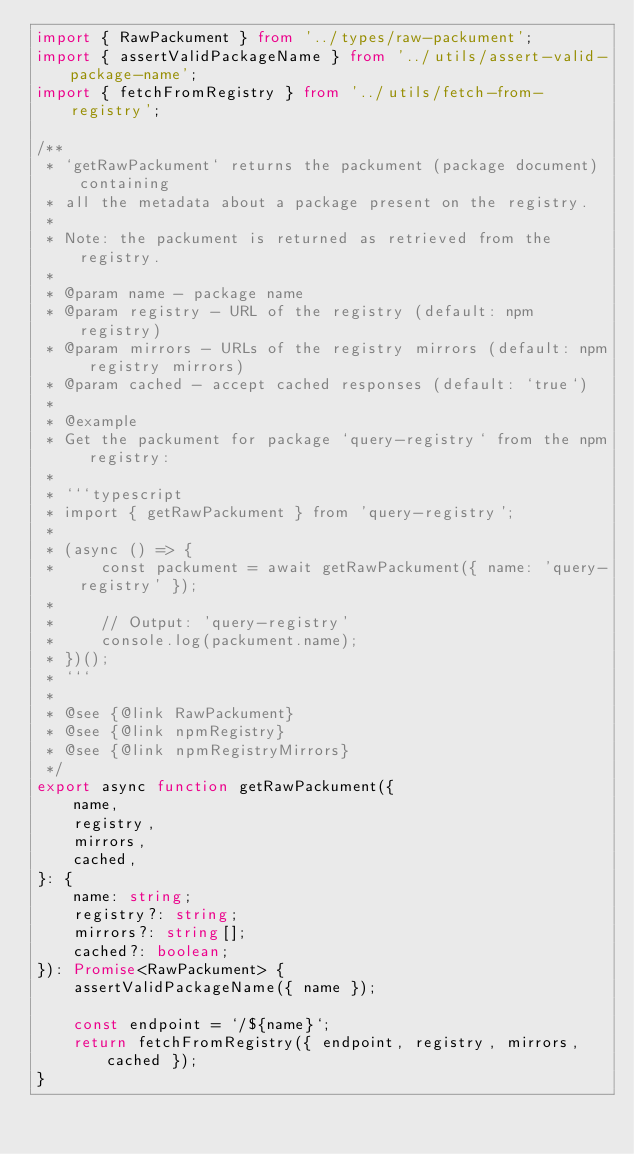Convert code to text. <code><loc_0><loc_0><loc_500><loc_500><_TypeScript_>import { RawPackument } from '../types/raw-packument';
import { assertValidPackageName } from '../utils/assert-valid-package-name';
import { fetchFromRegistry } from '../utils/fetch-from-registry';

/**
 * `getRawPackument` returns the packument (package document) containing
 * all the metadata about a package present on the registry.
 *
 * Note: the packument is returned as retrieved from the registry.
 *
 * @param name - package name
 * @param registry - URL of the registry (default: npm registry)
 * @param mirrors - URLs of the registry mirrors (default: npm registry mirrors)
 * @param cached - accept cached responses (default: `true`)
 *
 * @example
 * Get the packument for package `query-registry` from the npm registry:
 *
 * ```typescript
 * import { getRawPackument } from 'query-registry';
 *
 * (async () => {
 *     const packument = await getRawPackument({ name: 'query-registry' });
 *
 *     // Output: 'query-registry'
 *     console.log(packument.name);
 * })();
 * ```
 *
 * @see {@link RawPackument}
 * @see {@link npmRegistry}
 * @see {@link npmRegistryMirrors}
 */
export async function getRawPackument({
    name,
    registry,
    mirrors,
    cached,
}: {
    name: string;
    registry?: string;
    mirrors?: string[];
    cached?: boolean;
}): Promise<RawPackument> {
    assertValidPackageName({ name });

    const endpoint = `/${name}`;
    return fetchFromRegistry({ endpoint, registry, mirrors, cached });
}
</code> 